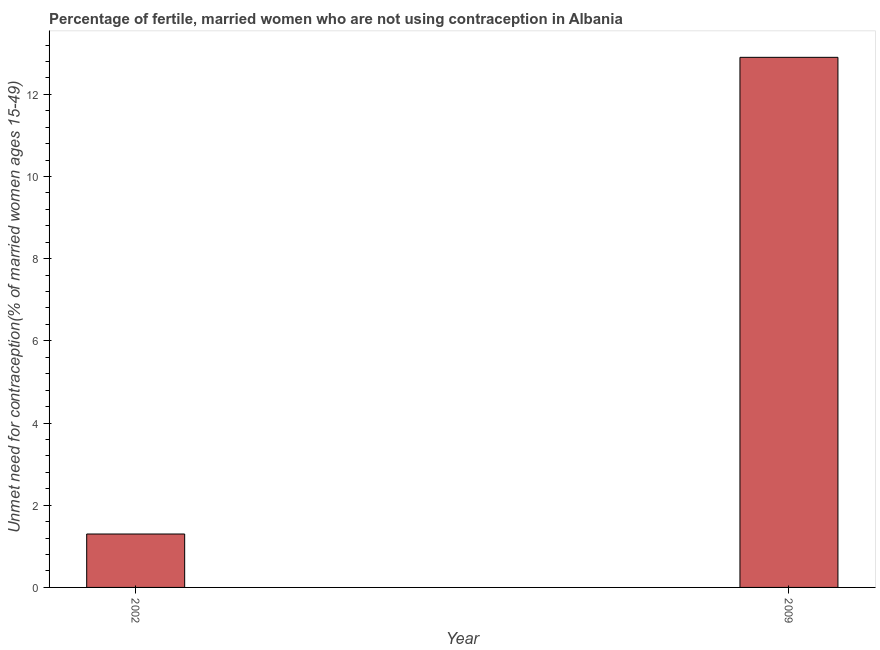Does the graph contain any zero values?
Make the answer very short. No. Does the graph contain grids?
Ensure brevity in your answer.  No. What is the title of the graph?
Your answer should be compact. Percentage of fertile, married women who are not using contraception in Albania. What is the label or title of the X-axis?
Keep it short and to the point. Year. What is the label or title of the Y-axis?
Keep it short and to the point.  Unmet need for contraception(% of married women ages 15-49). What is the number of married women who are not using contraception in 2002?
Provide a succinct answer. 1.3. Across all years, what is the maximum number of married women who are not using contraception?
Offer a very short reply. 12.9. Across all years, what is the minimum number of married women who are not using contraception?
Your answer should be compact. 1.3. What is the sum of the number of married women who are not using contraception?
Your answer should be very brief. 14.2. What is the average number of married women who are not using contraception per year?
Provide a succinct answer. 7.1. What is the median number of married women who are not using contraception?
Provide a succinct answer. 7.1. In how many years, is the number of married women who are not using contraception greater than 8 %?
Your answer should be very brief. 1. What is the ratio of the number of married women who are not using contraception in 2002 to that in 2009?
Your answer should be compact. 0.1. How many bars are there?
Offer a very short reply. 2. How many years are there in the graph?
Your response must be concise. 2. Are the values on the major ticks of Y-axis written in scientific E-notation?
Offer a terse response. No. What is the difference between the  Unmet need for contraception(% of married women ages 15-49) in 2002 and 2009?
Keep it short and to the point. -11.6. What is the ratio of the  Unmet need for contraception(% of married women ages 15-49) in 2002 to that in 2009?
Your response must be concise. 0.1. 